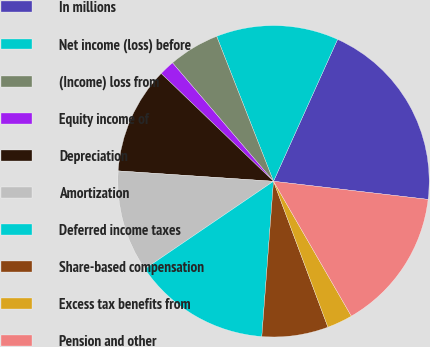<chart> <loc_0><loc_0><loc_500><loc_500><pie_chart><fcel>In millions<fcel>Net income (loss) before<fcel>(Income) loss from<fcel>Equity income of<fcel>Depreciation<fcel>Amortization<fcel>Deferred income taxes<fcel>Share-based compensation<fcel>Excess tax benefits from<fcel>Pension and other<nl><fcel>20.11%<fcel>12.7%<fcel>5.29%<fcel>1.59%<fcel>11.11%<fcel>10.58%<fcel>14.29%<fcel>6.88%<fcel>2.65%<fcel>14.81%<nl></chart> 